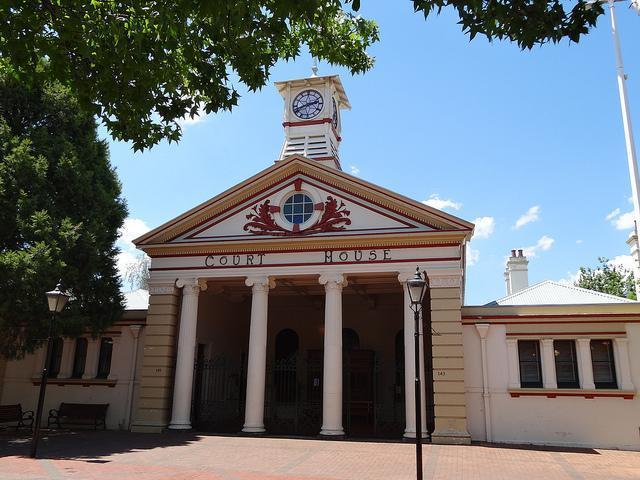How many cars are in the mirror?
Give a very brief answer. 0. 